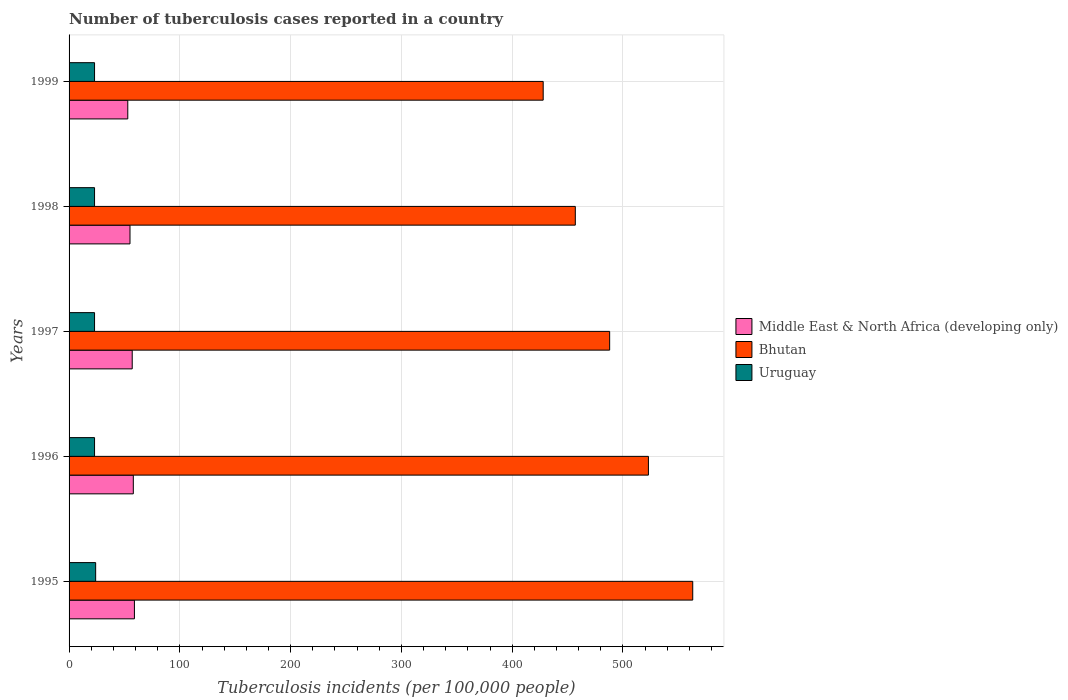How many different coloured bars are there?
Provide a short and direct response. 3. How many groups of bars are there?
Your answer should be compact. 5. How many bars are there on the 4th tick from the bottom?
Ensure brevity in your answer.  3. What is the label of the 4th group of bars from the top?
Give a very brief answer. 1996. In how many cases, is the number of bars for a given year not equal to the number of legend labels?
Give a very brief answer. 0. What is the number of tuberculosis cases reported in in Middle East & North Africa (developing only) in 1998?
Provide a succinct answer. 55. Across all years, what is the maximum number of tuberculosis cases reported in in Bhutan?
Make the answer very short. 563. Across all years, what is the minimum number of tuberculosis cases reported in in Bhutan?
Provide a succinct answer. 428. In which year was the number of tuberculosis cases reported in in Uruguay minimum?
Provide a short and direct response. 1996. What is the total number of tuberculosis cases reported in in Middle East & North Africa (developing only) in the graph?
Provide a short and direct response. 282. What is the difference between the number of tuberculosis cases reported in in Uruguay in 1997 and the number of tuberculosis cases reported in in Middle East & North Africa (developing only) in 1998?
Give a very brief answer. -32. What is the average number of tuberculosis cases reported in in Bhutan per year?
Provide a short and direct response. 491.8. In the year 1998, what is the difference between the number of tuberculosis cases reported in in Uruguay and number of tuberculosis cases reported in in Bhutan?
Provide a succinct answer. -434. What is the ratio of the number of tuberculosis cases reported in in Middle East & North Africa (developing only) in 1995 to that in 1997?
Ensure brevity in your answer.  1.04. What is the difference between the highest and the second highest number of tuberculosis cases reported in in Uruguay?
Provide a succinct answer. 1. What is the difference between the highest and the lowest number of tuberculosis cases reported in in Bhutan?
Provide a succinct answer. 135. In how many years, is the number of tuberculosis cases reported in in Bhutan greater than the average number of tuberculosis cases reported in in Bhutan taken over all years?
Offer a terse response. 2. What does the 1st bar from the top in 1999 represents?
Offer a very short reply. Uruguay. What does the 3rd bar from the bottom in 1999 represents?
Make the answer very short. Uruguay. Is it the case that in every year, the sum of the number of tuberculosis cases reported in in Middle East & North Africa (developing only) and number of tuberculosis cases reported in in Uruguay is greater than the number of tuberculosis cases reported in in Bhutan?
Your answer should be compact. No. Are all the bars in the graph horizontal?
Your answer should be very brief. Yes. How many years are there in the graph?
Offer a very short reply. 5. What is the difference between two consecutive major ticks on the X-axis?
Ensure brevity in your answer.  100. Where does the legend appear in the graph?
Offer a very short reply. Center right. How many legend labels are there?
Provide a short and direct response. 3. How are the legend labels stacked?
Provide a succinct answer. Vertical. What is the title of the graph?
Your answer should be very brief. Number of tuberculosis cases reported in a country. What is the label or title of the X-axis?
Give a very brief answer. Tuberculosis incidents (per 100,0 people). What is the Tuberculosis incidents (per 100,000 people) in Bhutan in 1995?
Your answer should be very brief. 563. What is the Tuberculosis incidents (per 100,000 people) in Middle East & North Africa (developing only) in 1996?
Your answer should be very brief. 58. What is the Tuberculosis incidents (per 100,000 people) of Bhutan in 1996?
Your response must be concise. 523. What is the Tuberculosis incidents (per 100,000 people) of Uruguay in 1996?
Give a very brief answer. 23. What is the Tuberculosis incidents (per 100,000 people) in Bhutan in 1997?
Give a very brief answer. 488. What is the Tuberculosis incidents (per 100,000 people) in Middle East & North Africa (developing only) in 1998?
Your answer should be compact. 55. What is the Tuberculosis incidents (per 100,000 people) of Bhutan in 1998?
Ensure brevity in your answer.  457. What is the Tuberculosis incidents (per 100,000 people) of Bhutan in 1999?
Offer a terse response. 428. What is the Tuberculosis incidents (per 100,000 people) of Uruguay in 1999?
Give a very brief answer. 23. Across all years, what is the maximum Tuberculosis incidents (per 100,000 people) of Middle East & North Africa (developing only)?
Make the answer very short. 59. Across all years, what is the maximum Tuberculosis incidents (per 100,000 people) of Bhutan?
Give a very brief answer. 563. Across all years, what is the maximum Tuberculosis incidents (per 100,000 people) of Uruguay?
Provide a short and direct response. 24. Across all years, what is the minimum Tuberculosis incidents (per 100,000 people) in Middle East & North Africa (developing only)?
Give a very brief answer. 53. Across all years, what is the minimum Tuberculosis incidents (per 100,000 people) of Bhutan?
Keep it short and to the point. 428. Across all years, what is the minimum Tuberculosis incidents (per 100,000 people) of Uruguay?
Keep it short and to the point. 23. What is the total Tuberculosis incidents (per 100,000 people) in Middle East & North Africa (developing only) in the graph?
Your response must be concise. 282. What is the total Tuberculosis incidents (per 100,000 people) of Bhutan in the graph?
Provide a succinct answer. 2459. What is the total Tuberculosis incidents (per 100,000 people) of Uruguay in the graph?
Make the answer very short. 116. What is the difference between the Tuberculosis incidents (per 100,000 people) in Middle East & North Africa (developing only) in 1995 and that in 1996?
Your response must be concise. 1. What is the difference between the Tuberculosis incidents (per 100,000 people) of Bhutan in 1995 and that in 1996?
Offer a very short reply. 40. What is the difference between the Tuberculosis incidents (per 100,000 people) in Bhutan in 1995 and that in 1997?
Your answer should be very brief. 75. What is the difference between the Tuberculosis incidents (per 100,000 people) of Uruguay in 1995 and that in 1997?
Offer a terse response. 1. What is the difference between the Tuberculosis incidents (per 100,000 people) in Bhutan in 1995 and that in 1998?
Your answer should be compact. 106. What is the difference between the Tuberculosis incidents (per 100,000 people) of Bhutan in 1995 and that in 1999?
Your answer should be very brief. 135. What is the difference between the Tuberculosis incidents (per 100,000 people) in Uruguay in 1995 and that in 1999?
Offer a very short reply. 1. What is the difference between the Tuberculosis incidents (per 100,000 people) in Middle East & North Africa (developing only) in 1996 and that in 1997?
Offer a terse response. 1. What is the difference between the Tuberculosis incidents (per 100,000 people) of Bhutan in 1996 and that in 1997?
Keep it short and to the point. 35. What is the difference between the Tuberculosis incidents (per 100,000 people) in Bhutan in 1996 and that in 1998?
Provide a succinct answer. 66. What is the difference between the Tuberculosis incidents (per 100,000 people) of Uruguay in 1996 and that in 1998?
Offer a terse response. 0. What is the difference between the Tuberculosis incidents (per 100,000 people) in Middle East & North Africa (developing only) in 1996 and that in 1999?
Give a very brief answer. 5. What is the difference between the Tuberculosis incidents (per 100,000 people) in Bhutan in 1996 and that in 1999?
Provide a short and direct response. 95. What is the difference between the Tuberculosis incidents (per 100,000 people) of Middle East & North Africa (developing only) in 1997 and that in 1998?
Your answer should be very brief. 2. What is the difference between the Tuberculosis incidents (per 100,000 people) of Bhutan in 1997 and that in 1998?
Provide a succinct answer. 31. What is the difference between the Tuberculosis incidents (per 100,000 people) in Uruguay in 1997 and that in 1998?
Your response must be concise. 0. What is the difference between the Tuberculosis incidents (per 100,000 people) in Middle East & North Africa (developing only) in 1997 and that in 1999?
Your answer should be very brief. 4. What is the difference between the Tuberculosis incidents (per 100,000 people) of Middle East & North Africa (developing only) in 1995 and the Tuberculosis incidents (per 100,000 people) of Bhutan in 1996?
Offer a terse response. -464. What is the difference between the Tuberculosis incidents (per 100,000 people) in Middle East & North Africa (developing only) in 1995 and the Tuberculosis incidents (per 100,000 people) in Uruguay in 1996?
Your answer should be very brief. 36. What is the difference between the Tuberculosis incidents (per 100,000 people) in Bhutan in 1995 and the Tuberculosis incidents (per 100,000 people) in Uruguay in 1996?
Make the answer very short. 540. What is the difference between the Tuberculosis incidents (per 100,000 people) in Middle East & North Africa (developing only) in 1995 and the Tuberculosis incidents (per 100,000 people) in Bhutan in 1997?
Your response must be concise. -429. What is the difference between the Tuberculosis incidents (per 100,000 people) of Bhutan in 1995 and the Tuberculosis incidents (per 100,000 people) of Uruguay in 1997?
Offer a terse response. 540. What is the difference between the Tuberculosis incidents (per 100,000 people) in Middle East & North Africa (developing only) in 1995 and the Tuberculosis incidents (per 100,000 people) in Bhutan in 1998?
Offer a very short reply. -398. What is the difference between the Tuberculosis incidents (per 100,000 people) in Bhutan in 1995 and the Tuberculosis incidents (per 100,000 people) in Uruguay in 1998?
Provide a short and direct response. 540. What is the difference between the Tuberculosis incidents (per 100,000 people) in Middle East & North Africa (developing only) in 1995 and the Tuberculosis incidents (per 100,000 people) in Bhutan in 1999?
Provide a short and direct response. -369. What is the difference between the Tuberculosis incidents (per 100,000 people) of Bhutan in 1995 and the Tuberculosis incidents (per 100,000 people) of Uruguay in 1999?
Provide a short and direct response. 540. What is the difference between the Tuberculosis incidents (per 100,000 people) in Middle East & North Africa (developing only) in 1996 and the Tuberculosis incidents (per 100,000 people) in Bhutan in 1997?
Provide a succinct answer. -430. What is the difference between the Tuberculosis incidents (per 100,000 people) of Middle East & North Africa (developing only) in 1996 and the Tuberculosis incidents (per 100,000 people) of Uruguay in 1997?
Your answer should be very brief. 35. What is the difference between the Tuberculosis incidents (per 100,000 people) in Middle East & North Africa (developing only) in 1996 and the Tuberculosis incidents (per 100,000 people) in Bhutan in 1998?
Your answer should be very brief. -399. What is the difference between the Tuberculosis incidents (per 100,000 people) of Bhutan in 1996 and the Tuberculosis incidents (per 100,000 people) of Uruguay in 1998?
Your response must be concise. 500. What is the difference between the Tuberculosis incidents (per 100,000 people) in Middle East & North Africa (developing only) in 1996 and the Tuberculosis incidents (per 100,000 people) in Bhutan in 1999?
Ensure brevity in your answer.  -370. What is the difference between the Tuberculosis incidents (per 100,000 people) of Bhutan in 1996 and the Tuberculosis incidents (per 100,000 people) of Uruguay in 1999?
Provide a succinct answer. 500. What is the difference between the Tuberculosis incidents (per 100,000 people) of Middle East & North Africa (developing only) in 1997 and the Tuberculosis incidents (per 100,000 people) of Bhutan in 1998?
Offer a terse response. -400. What is the difference between the Tuberculosis incidents (per 100,000 people) in Bhutan in 1997 and the Tuberculosis incidents (per 100,000 people) in Uruguay in 1998?
Make the answer very short. 465. What is the difference between the Tuberculosis incidents (per 100,000 people) in Middle East & North Africa (developing only) in 1997 and the Tuberculosis incidents (per 100,000 people) in Bhutan in 1999?
Keep it short and to the point. -371. What is the difference between the Tuberculosis incidents (per 100,000 people) of Bhutan in 1997 and the Tuberculosis incidents (per 100,000 people) of Uruguay in 1999?
Your answer should be very brief. 465. What is the difference between the Tuberculosis incidents (per 100,000 people) of Middle East & North Africa (developing only) in 1998 and the Tuberculosis incidents (per 100,000 people) of Bhutan in 1999?
Offer a terse response. -373. What is the difference between the Tuberculosis incidents (per 100,000 people) in Middle East & North Africa (developing only) in 1998 and the Tuberculosis incidents (per 100,000 people) in Uruguay in 1999?
Keep it short and to the point. 32. What is the difference between the Tuberculosis incidents (per 100,000 people) in Bhutan in 1998 and the Tuberculosis incidents (per 100,000 people) in Uruguay in 1999?
Ensure brevity in your answer.  434. What is the average Tuberculosis incidents (per 100,000 people) of Middle East & North Africa (developing only) per year?
Your answer should be compact. 56.4. What is the average Tuberculosis incidents (per 100,000 people) of Bhutan per year?
Offer a very short reply. 491.8. What is the average Tuberculosis incidents (per 100,000 people) in Uruguay per year?
Offer a very short reply. 23.2. In the year 1995, what is the difference between the Tuberculosis incidents (per 100,000 people) in Middle East & North Africa (developing only) and Tuberculosis incidents (per 100,000 people) in Bhutan?
Your answer should be compact. -504. In the year 1995, what is the difference between the Tuberculosis incidents (per 100,000 people) of Middle East & North Africa (developing only) and Tuberculosis incidents (per 100,000 people) of Uruguay?
Ensure brevity in your answer.  35. In the year 1995, what is the difference between the Tuberculosis incidents (per 100,000 people) of Bhutan and Tuberculosis incidents (per 100,000 people) of Uruguay?
Ensure brevity in your answer.  539. In the year 1996, what is the difference between the Tuberculosis incidents (per 100,000 people) in Middle East & North Africa (developing only) and Tuberculosis incidents (per 100,000 people) in Bhutan?
Your response must be concise. -465. In the year 1997, what is the difference between the Tuberculosis incidents (per 100,000 people) in Middle East & North Africa (developing only) and Tuberculosis incidents (per 100,000 people) in Bhutan?
Give a very brief answer. -431. In the year 1997, what is the difference between the Tuberculosis incidents (per 100,000 people) of Middle East & North Africa (developing only) and Tuberculosis incidents (per 100,000 people) of Uruguay?
Offer a very short reply. 34. In the year 1997, what is the difference between the Tuberculosis incidents (per 100,000 people) in Bhutan and Tuberculosis incidents (per 100,000 people) in Uruguay?
Keep it short and to the point. 465. In the year 1998, what is the difference between the Tuberculosis incidents (per 100,000 people) of Middle East & North Africa (developing only) and Tuberculosis incidents (per 100,000 people) of Bhutan?
Your response must be concise. -402. In the year 1998, what is the difference between the Tuberculosis incidents (per 100,000 people) in Bhutan and Tuberculosis incidents (per 100,000 people) in Uruguay?
Your answer should be compact. 434. In the year 1999, what is the difference between the Tuberculosis incidents (per 100,000 people) in Middle East & North Africa (developing only) and Tuberculosis incidents (per 100,000 people) in Bhutan?
Your response must be concise. -375. In the year 1999, what is the difference between the Tuberculosis incidents (per 100,000 people) in Middle East & North Africa (developing only) and Tuberculosis incidents (per 100,000 people) in Uruguay?
Keep it short and to the point. 30. In the year 1999, what is the difference between the Tuberculosis incidents (per 100,000 people) of Bhutan and Tuberculosis incidents (per 100,000 people) of Uruguay?
Your answer should be very brief. 405. What is the ratio of the Tuberculosis incidents (per 100,000 people) of Middle East & North Africa (developing only) in 1995 to that in 1996?
Offer a very short reply. 1.02. What is the ratio of the Tuberculosis incidents (per 100,000 people) in Bhutan in 1995 to that in 1996?
Make the answer very short. 1.08. What is the ratio of the Tuberculosis incidents (per 100,000 people) of Uruguay in 1995 to that in 1996?
Keep it short and to the point. 1.04. What is the ratio of the Tuberculosis incidents (per 100,000 people) in Middle East & North Africa (developing only) in 1995 to that in 1997?
Offer a terse response. 1.04. What is the ratio of the Tuberculosis incidents (per 100,000 people) of Bhutan in 1995 to that in 1997?
Provide a succinct answer. 1.15. What is the ratio of the Tuberculosis incidents (per 100,000 people) of Uruguay in 1995 to that in 1997?
Keep it short and to the point. 1.04. What is the ratio of the Tuberculosis incidents (per 100,000 people) in Middle East & North Africa (developing only) in 1995 to that in 1998?
Offer a very short reply. 1.07. What is the ratio of the Tuberculosis incidents (per 100,000 people) in Bhutan in 1995 to that in 1998?
Your response must be concise. 1.23. What is the ratio of the Tuberculosis incidents (per 100,000 people) in Uruguay in 1995 to that in 1998?
Offer a terse response. 1.04. What is the ratio of the Tuberculosis incidents (per 100,000 people) of Middle East & North Africa (developing only) in 1995 to that in 1999?
Provide a succinct answer. 1.11. What is the ratio of the Tuberculosis incidents (per 100,000 people) of Bhutan in 1995 to that in 1999?
Give a very brief answer. 1.32. What is the ratio of the Tuberculosis incidents (per 100,000 people) in Uruguay in 1995 to that in 1999?
Offer a very short reply. 1.04. What is the ratio of the Tuberculosis incidents (per 100,000 people) of Middle East & North Africa (developing only) in 1996 to that in 1997?
Give a very brief answer. 1.02. What is the ratio of the Tuberculosis incidents (per 100,000 people) of Bhutan in 1996 to that in 1997?
Offer a terse response. 1.07. What is the ratio of the Tuberculosis incidents (per 100,000 people) of Uruguay in 1996 to that in 1997?
Keep it short and to the point. 1. What is the ratio of the Tuberculosis incidents (per 100,000 people) of Middle East & North Africa (developing only) in 1996 to that in 1998?
Your answer should be very brief. 1.05. What is the ratio of the Tuberculosis incidents (per 100,000 people) in Bhutan in 1996 to that in 1998?
Your answer should be compact. 1.14. What is the ratio of the Tuberculosis incidents (per 100,000 people) in Middle East & North Africa (developing only) in 1996 to that in 1999?
Your answer should be very brief. 1.09. What is the ratio of the Tuberculosis incidents (per 100,000 people) in Bhutan in 1996 to that in 1999?
Provide a short and direct response. 1.22. What is the ratio of the Tuberculosis incidents (per 100,000 people) of Middle East & North Africa (developing only) in 1997 to that in 1998?
Provide a short and direct response. 1.04. What is the ratio of the Tuberculosis incidents (per 100,000 people) in Bhutan in 1997 to that in 1998?
Your answer should be compact. 1.07. What is the ratio of the Tuberculosis incidents (per 100,000 people) of Middle East & North Africa (developing only) in 1997 to that in 1999?
Your response must be concise. 1.08. What is the ratio of the Tuberculosis incidents (per 100,000 people) in Bhutan in 1997 to that in 1999?
Offer a very short reply. 1.14. What is the ratio of the Tuberculosis incidents (per 100,000 people) in Middle East & North Africa (developing only) in 1998 to that in 1999?
Your answer should be compact. 1.04. What is the ratio of the Tuberculosis incidents (per 100,000 people) in Bhutan in 1998 to that in 1999?
Offer a terse response. 1.07. What is the ratio of the Tuberculosis incidents (per 100,000 people) of Uruguay in 1998 to that in 1999?
Your response must be concise. 1. What is the difference between the highest and the second highest Tuberculosis incidents (per 100,000 people) of Middle East & North Africa (developing only)?
Keep it short and to the point. 1. What is the difference between the highest and the second highest Tuberculosis incidents (per 100,000 people) of Bhutan?
Give a very brief answer. 40. What is the difference between the highest and the second highest Tuberculosis incidents (per 100,000 people) of Uruguay?
Offer a terse response. 1. What is the difference between the highest and the lowest Tuberculosis incidents (per 100,000 people) in Middle East & North Africa (developing only)?
Make the answer very short. 6. What is the difference between the highest and the lowest Tuberculosis incidents (per 100,000 people) in Bhutan?
Your answer should be compact. 135. What is the difference between the highest and the lowest Tuberculosis incidents (per 100,000 people) of Uruguay?
Make the answer very short. 1. 